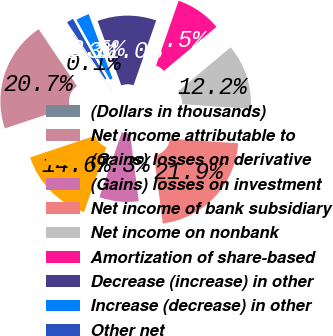Convert chart to OTSL. <chart><loc_0><loc_0><loc_500><loc_500><pie_chart><fcel>(Dollars in thousands)<fcel>Net income attributable to<fcel>(Gains) losses on derivative<fcel>(Gains) losses on investment<fcel>Net income of bank subsidiary<fcel>Net income on nonbank<fcel>Amortization of share-based<fcel>Decrease (increase) in other<fcel>Increase (decrease) in other<fcel>Other net<nl><fcel>0.06%<fcel>20.67%<fcel>14.61%<fcel>7.33%<fcel>21.88%<fcel>12.18%<fcel>8.54%<fcel>10.97%<fcel>2.48%<fcel>1.27%<nl></chart> 